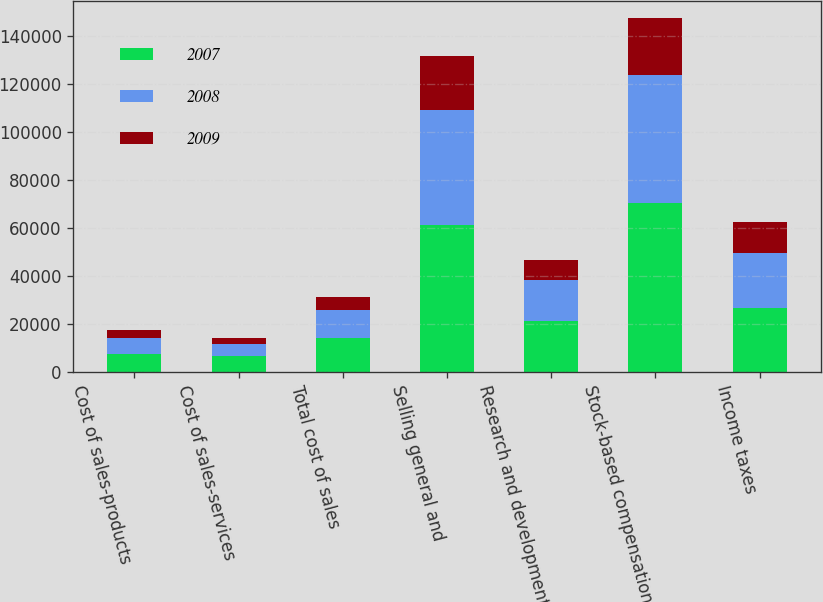Convert chart. <chart><loc_0><loc_0><loc_500><loc_500><stacked_bar_chart><ecel><fcel>Cost of sales-products<fcel>Cost of sales-services<fcel>Total cost of sales<fcel>Selling general and<fcel>Research and development<fcel>Stock-based compensation<fcel>Income taxes<nl><fcel>2007<fcel>7653<fcel>6634<fcel>14287<fcel>61271<fcel>21423<fcel>70462<fcel>26519<nl><fcel>2008<fcel>6311<fcel>5077<fcel>11388<fcel>48149<fcel>17109<fcel>53441<fcel>23205<nl><fcel>2009<fcel>3472<fcel>2276<fcel>5748<fcel>22560<fcel>7984<fcel>23641<fcel>12651<nl></chart> 